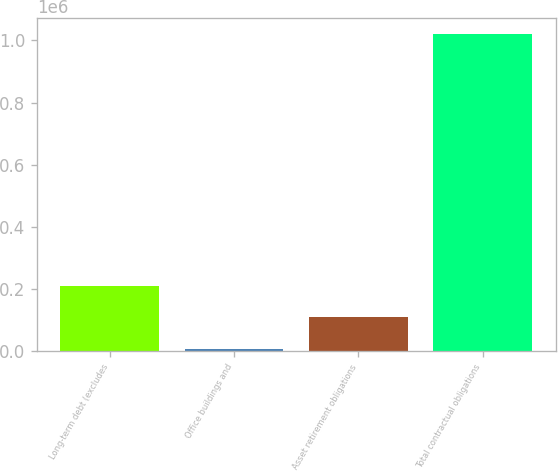<chart> <loc_0><loc_0><loc_500><loc_500><bar_chart><fcel>Long-term debt (excludes<fcel>Office buildings and<fcel>Asset retirement obligations<fcel>Total contractual obligations<nl><fcel>209866<fcel>7289<fcel>108577<fcel>1.02017e+06<nl></chart> 